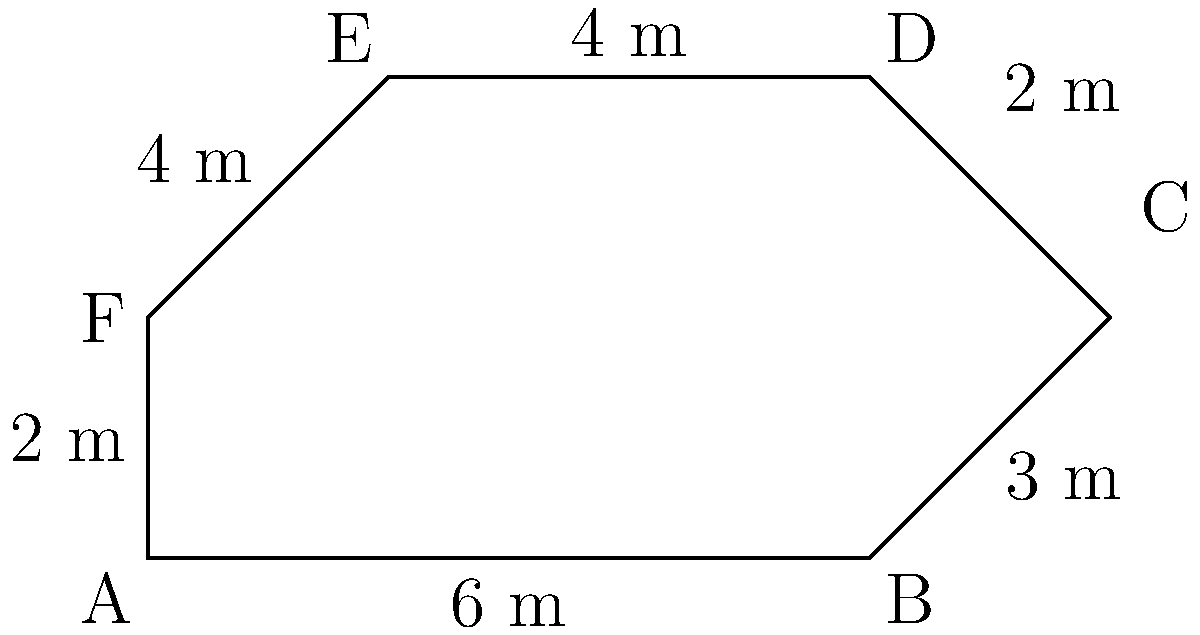A proposed city park has an irregular hexagonal shape as shown in the diagram. Given the measurements of each side, calculate the perimeter of the park. How much fencing would be required to enclose the entire park? To calculate the perimeter of the park, we need to sum up the lengths of all sides:

1. Side AB: 6 m
2. Side BC: 3 m
3. Side CD: 2 m
4. Side DE: 4 m
5. Side EF: 4 m
6. Side FA: 2 m

Adding these lengths:

$$\text{Perimeter} = 6 + 3 + 2 + 4 + 4 + 2 = 21 \text{ m}$$

Therefore, the perimeter of the park is 21 meters, which is also the amount of fencing required to enclose the entire park.
Answer: 21 meters 